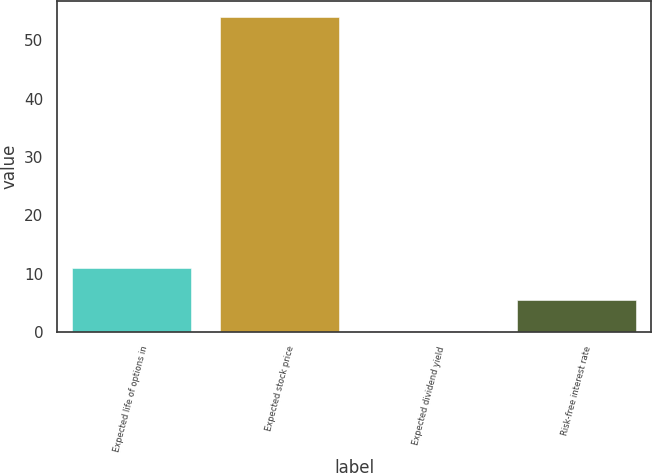Convert chart to OTSL. <chart><loc_0><loc_0><loc_500><loc_500><bar_chart><fcel>Expected life of options in<fcel>Expected stock price<fcel>Expected dividend yield<fcel>Risk-free interest rate<nl><fcel>10.88<fcel>54<fcel>0.1<fcel>5.49<nl></chart> 